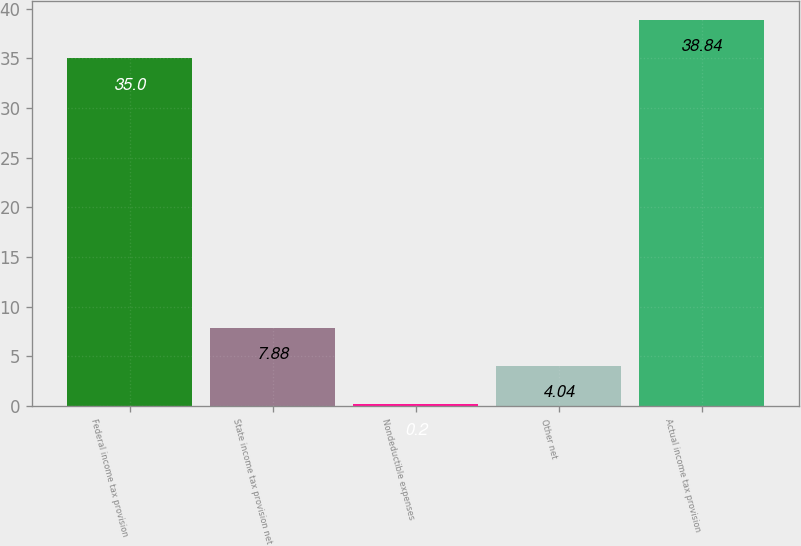Convert chart to OTSL. <chart><loc_0><loc_0><loc_500><loc_500><bar_chart><fcel>Federal income tax provision<fcel>State income tax provision net<fcel>Nondeductible expenses<fcel>Other net<fcel>Actual income tax provision<nl><fcel>35<fcel>7.88<fcel>0.2<fcel>4.04<fcel>38.84<nl></chart> 